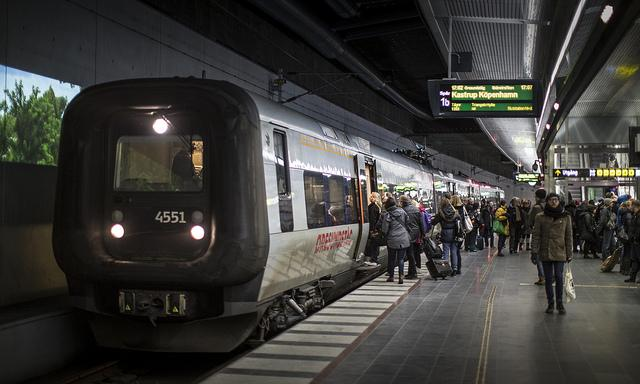What can be seen to the left of the train? trees 